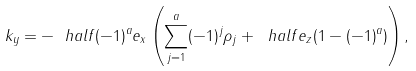<formula> <loc_0><loc_0><loc_500><loc_500>k _ { y } = - \ h a l f ( - 1 ) ^ { a } e _ { x } \left ( \sum _ { j = 1 } ^ { a } ( - 1 ) ^ { j } \rho _ { j } + \ h a l f e _ { z } ( 1 - ( - 1 ) ^ { a } ) \right ) ,</formula> 